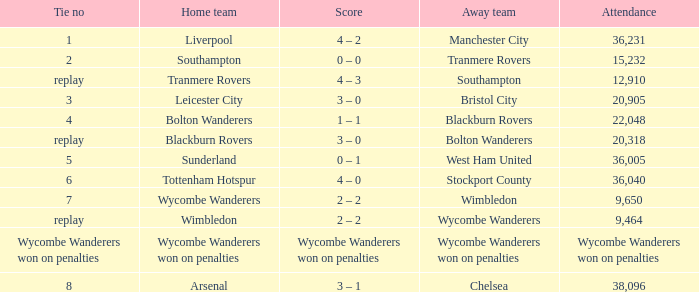What was the score for the game where the home team was Wycombe Wanderers? 2 – 2. 